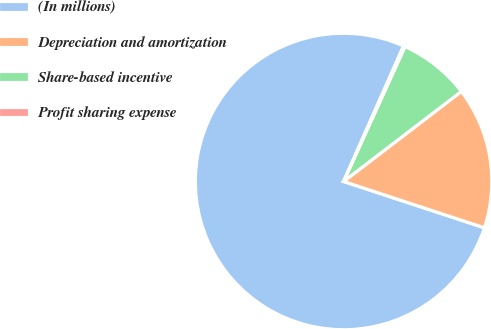<chart> <loc_0><loc_0><loc_500><loc_500><pie_chart><fcel>(In millions)<fcel>Depreciation and amortization<fcel>Share-based incentive<fcel>Profit sharing expense<nl><fcel>76.57%<fcel>15.45%<fcel>7.81%<fcel>0.17%<nl></chart> 